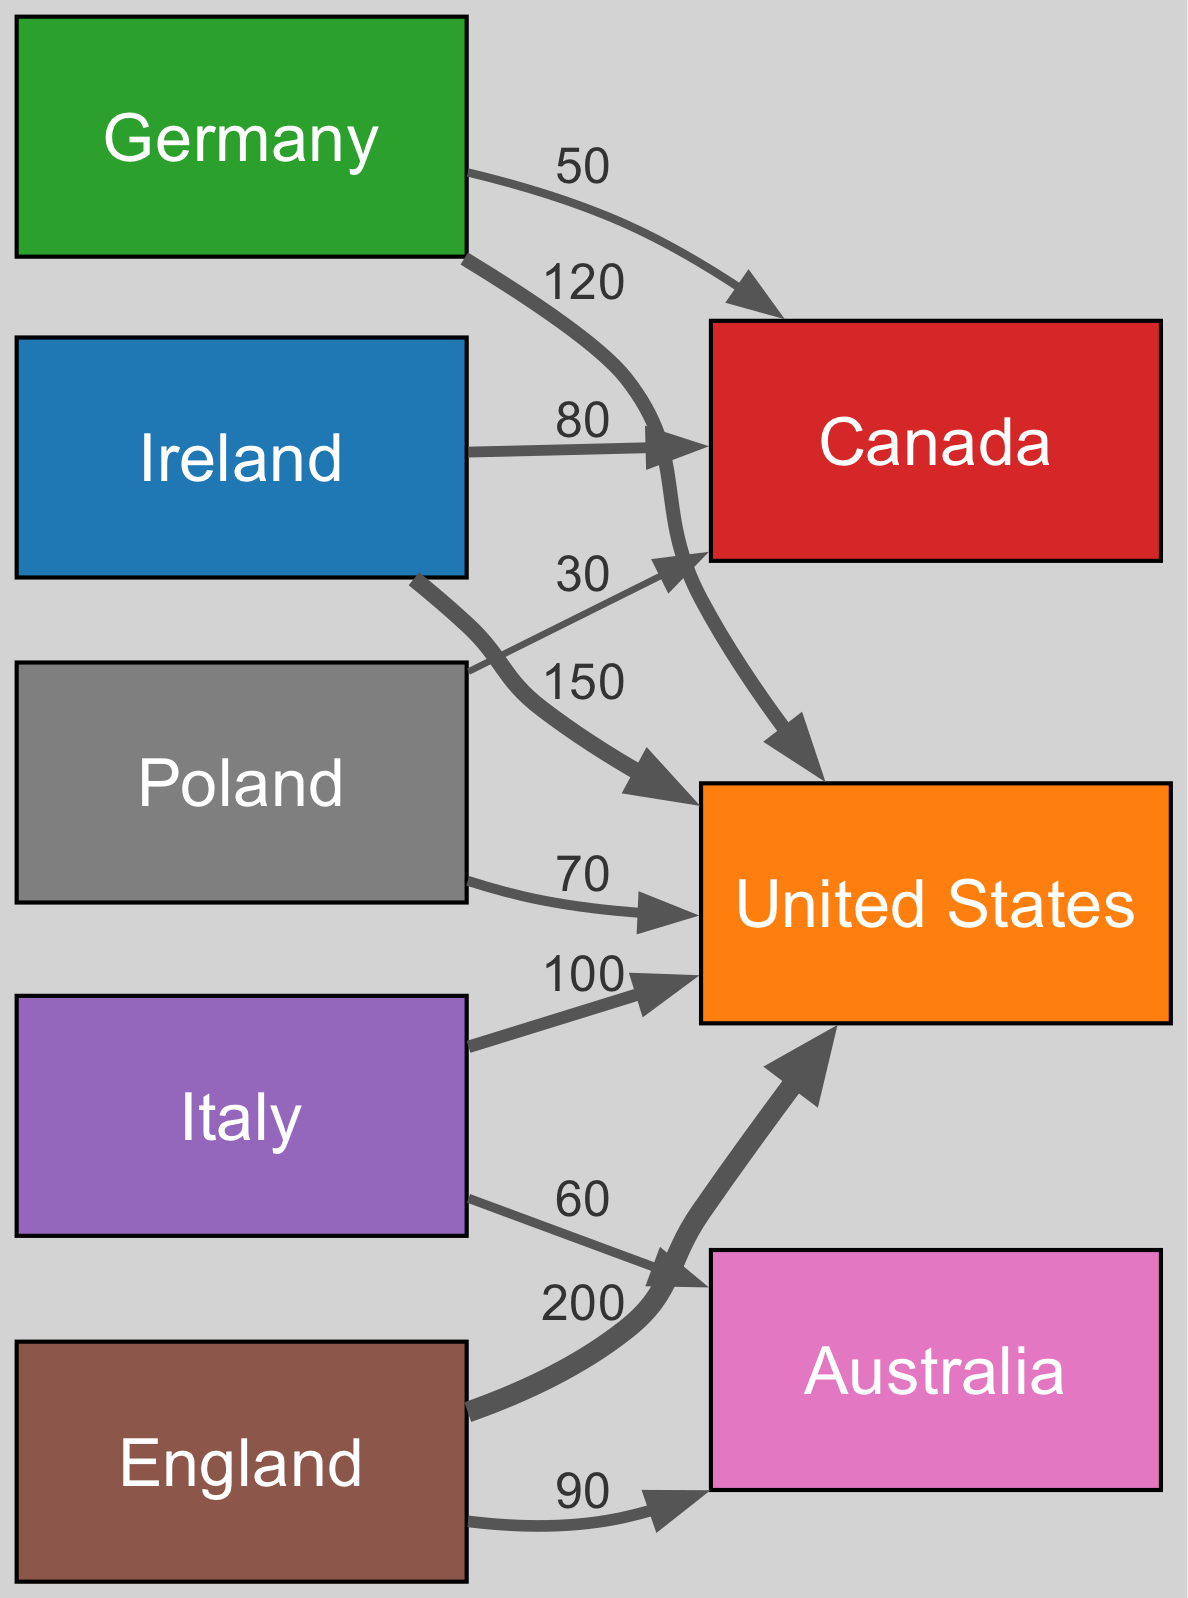What is the total migration value from Ireland to the USA? The diagram shows a direct flow from Ireland to the USA with a value of 150. Thus, the total migration value from Ireland to the USA is simply that value.
Answer: 150 How many countries are shown in the diagram? The diagram has a list of countries represented as nodes. Counting them, there are a total of 8 countries: Ireland, USA, Germany, Canada, Italy, England, Australia, and Poland.
Answer: 8 Which country has the highest migration to the USA? By looking at the amounts in the diagram, England has the highest value of 200 for migration to the USA, compared to other countries.
Answer: England What is the total migration value from Germany to Canada? The diagram indicates a specific flow from Germany to Canada with a value of 50. This figure represents the total migration from Germany to Canada.
Answer: 50 Which two countries send the most immigrants to Australia? The diagram indicates two flows: from Italy (60) and from England (90) to Australia. When combined, these two flows represent the total migration to Australia.
Answer: England and Italy What is the least amount of migrants flowing from Poland? The diagram shows two flows from Poland, one to the USA (70) and another to Canada (30). The lesser of the two values indicates the least amount of migrants flowing from Poland, which is the latter.
Answer: 30 How many total migrants moved from Italy to other countries? The diagram shows two flows from Italy: one to the USA (100) and another to Australia (60). Adding these two values gives the total number of migrants moving from Italy to other countries.
Answer: 160 What is the relationship between Germany and the USA in terms of migration? The diagram shows a direct link from Germany to the USA with a value of 120. This indicates the migration flow from Germany to the USA.
Answer: 120 Which country has more immigration to Canada, Ireland or Poland? The diagram shows that Ireland sends 80 migrants to Canada, while Poland sends 30. Thus, the comparison shows that Ireland has the larger flow.
Answer: Ireland 